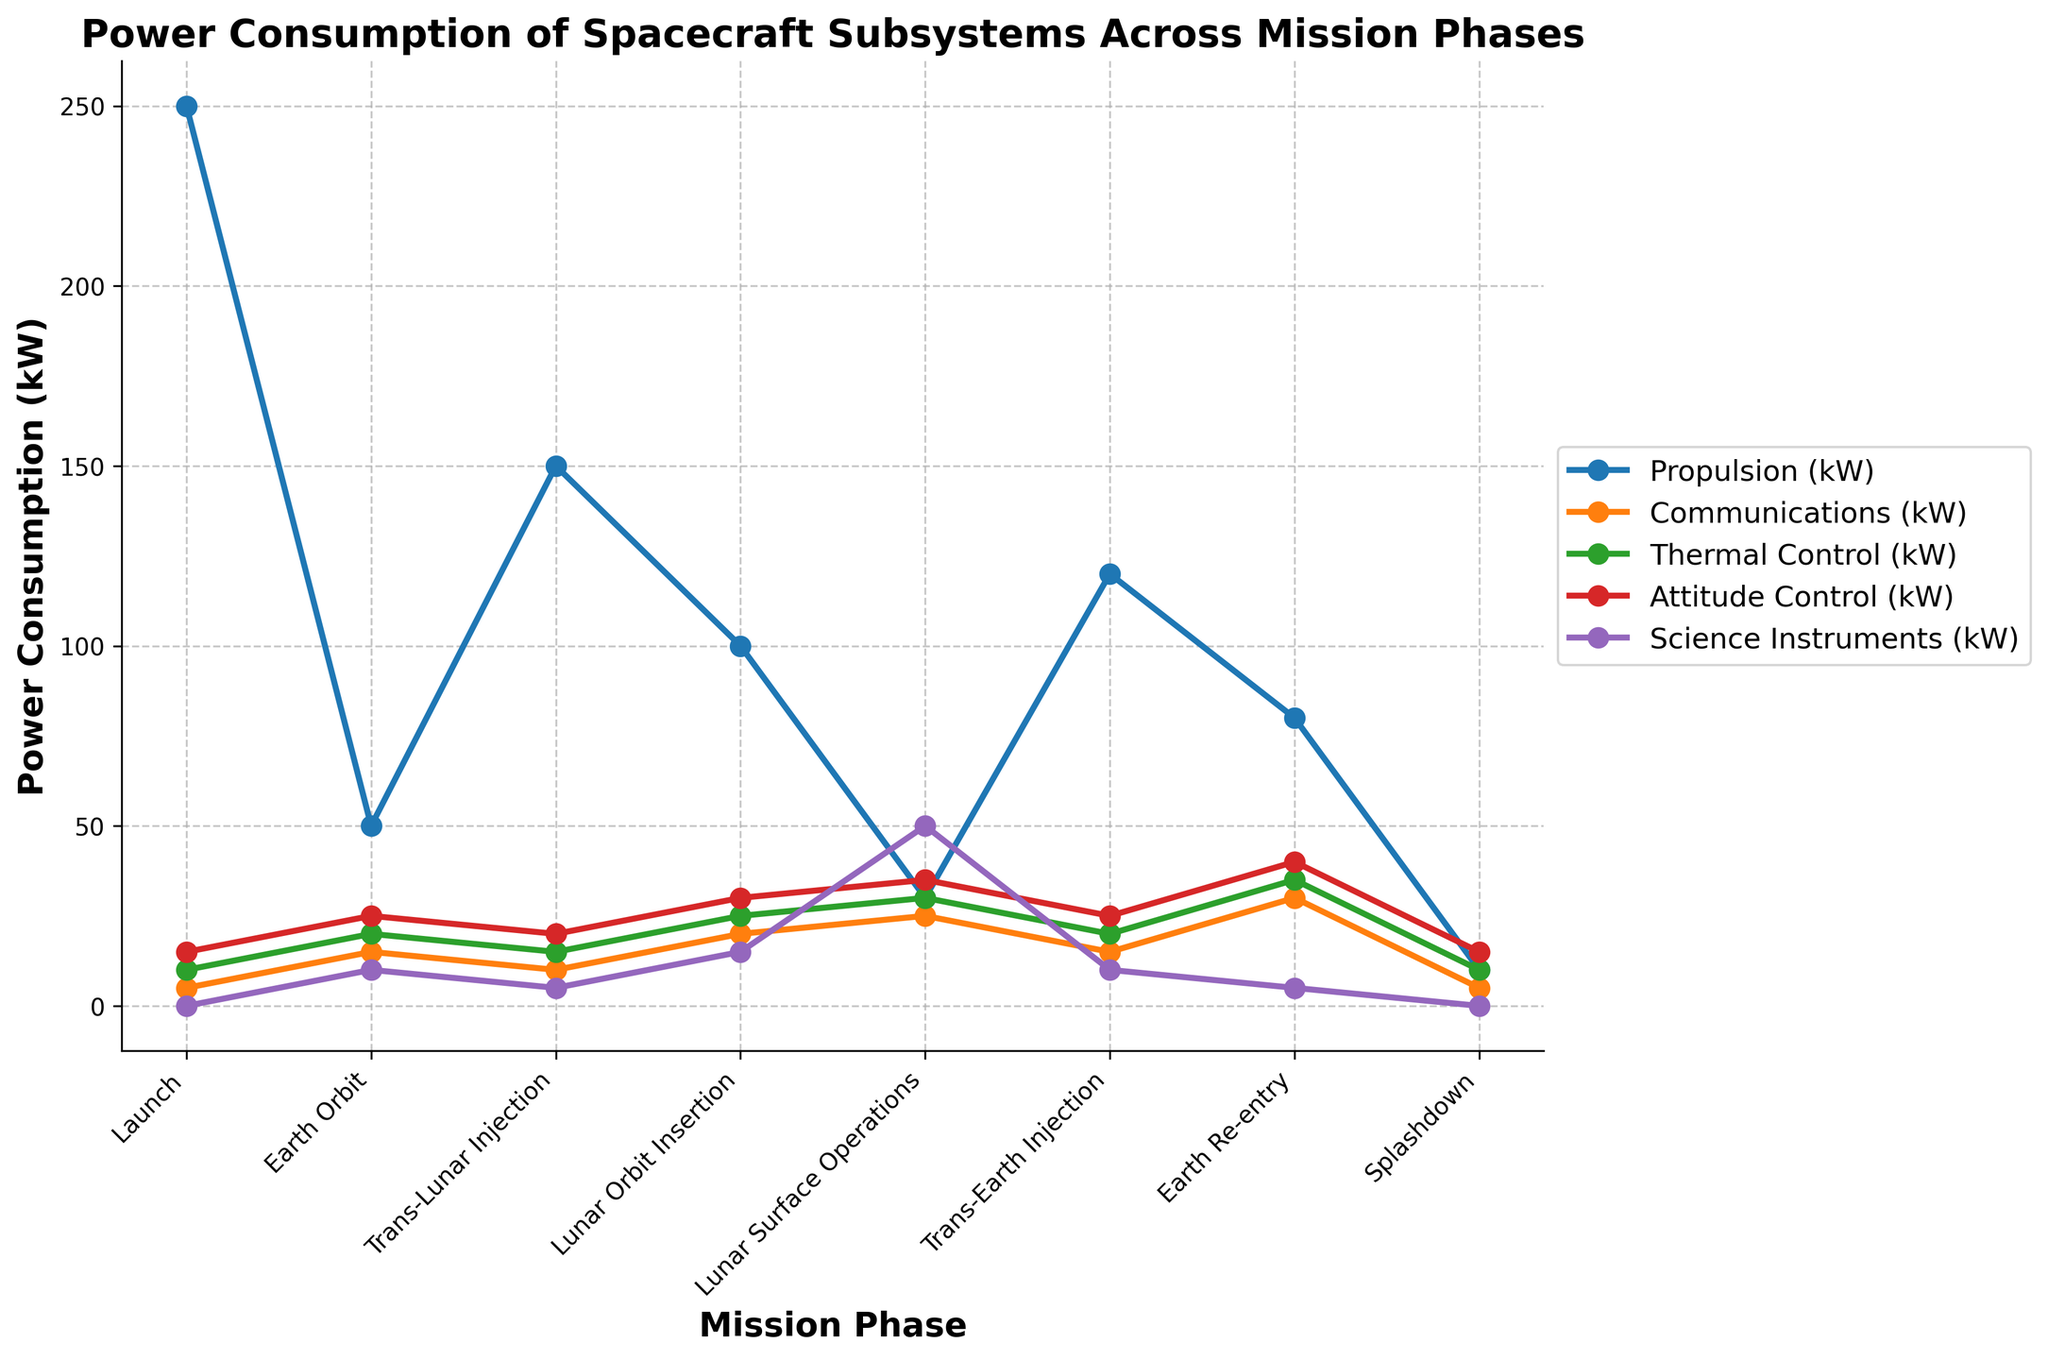Which spacecraft subsystem has the highest power consumption during 'Launch'? During 'Launch', we look for the highest y-value among the different subsystem lines. The 'Propulsion' subsystem has the highest power consumption at 250 kW.
Answer: Propulsion Which mission phase has the lowest power consumption for 'Thermal Control'? Review the power consumption values for the 'Thermal Control' line across all mission phases. The lowest power consumption is during 'Launch' at 10 kW.
Answer: Launch What is the total power consumption for 'Science Instruments' across all phases? Add up the power consumption values for 'Science Instruments' across all phases: 0 + 10 + 5 + 15 + 50 + 10 + 5 + 0 = 95 kW.
Answer: 95 kW How does the power consumption for 'Communications' change from 'Lunar Orbit Insertion' to 'Earth Re-entry'? Compare the y-values of the 'Communications' line at 'Lunar Orbit Insertion' (20 kW) and 'Earth Re-entry' (30 kW). There's an increase of 10 kW.
Answer: It increases by 10 kW Which two subsystems have the same power consumption value in the 'Splashdown' phase? Examine the y-values during 'Splashdown': 'Propulsion' (10 kW) and 'Thermal Control' (10 kW) are equal.
Answer: Propulsion and Thermal Control Compare the power consumption in 'Attitude Control' during 'Earth Orbit' and 'Earth Re-entry'. Which one is higher? 'Attitude Control' at 'Earth Orbit' has a value of 25 kW, whereas at 'Earth Re-entry', it is 40 kW. Hence, 'Earth Re-entry' is higher.
Answer: Earth Re-entry What is the difference in power consumption for 'Propulsion' between 'Trans-Lunar Injection' and 'Lunar Surface Operations'? Subtract the 'Lunar Surface Operations' value from 'Trans-Lunar Injection': 150 kW - 30 kW = 120 kW.
Answer: 120 kW Determine the average power consumption for 'Communications' throughout the mission. Add up all 'Communications' values: 5 + 15 + 10 + 20 + 25 + 15 + 30 + 5 = 125 kW. Then, divide by the number of phases (8): 125 / 8 = 15.625 kW.
Answer: 15.625 kW Does 'Thermal Control' show a consistent upward trend in power consumption from 'Launch' to 'Earth Re-entry'? Analyze the values of 'Thermal Control': 10 -> 20 -> 15 -> 25 -> 30 -> 20 -> 35 -> 40, which generally increases with some variability.
Answer: No 